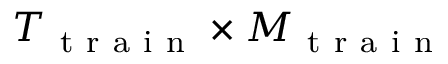Convert formula to latex. <formula><loc_0><loc_0><loc_500><loc_500>T _ { t r a i n } \times M _ { t r a i n }</formula> 